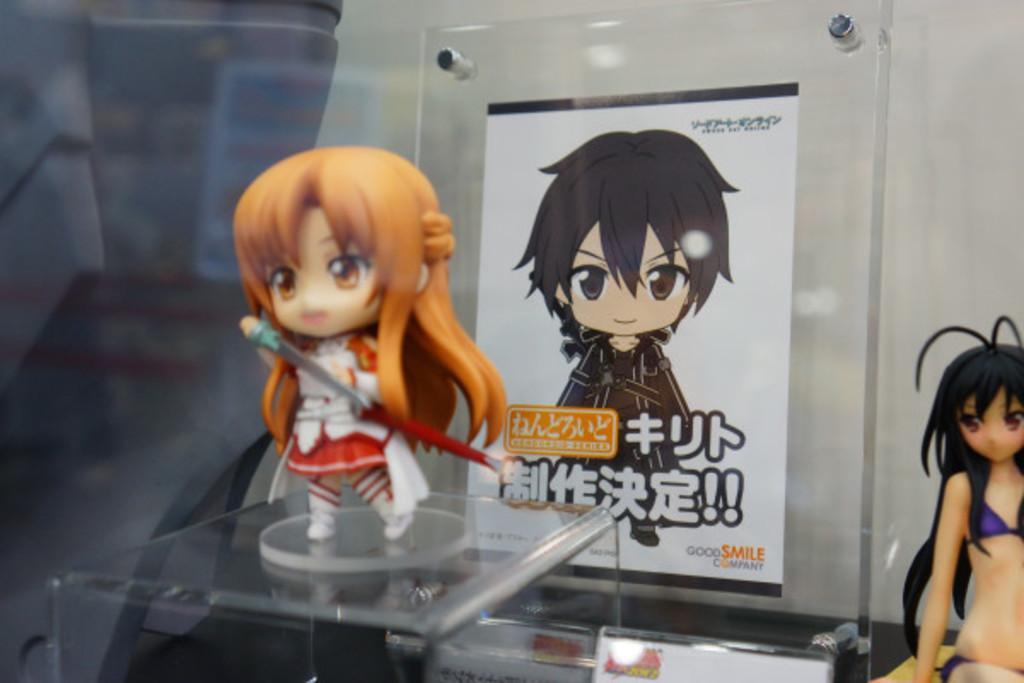How would you summarize this image in a sentence or two? In this image I can see few dollars, a poster and on it I can see something is written. I can also see this image is little bit blurry from background. 